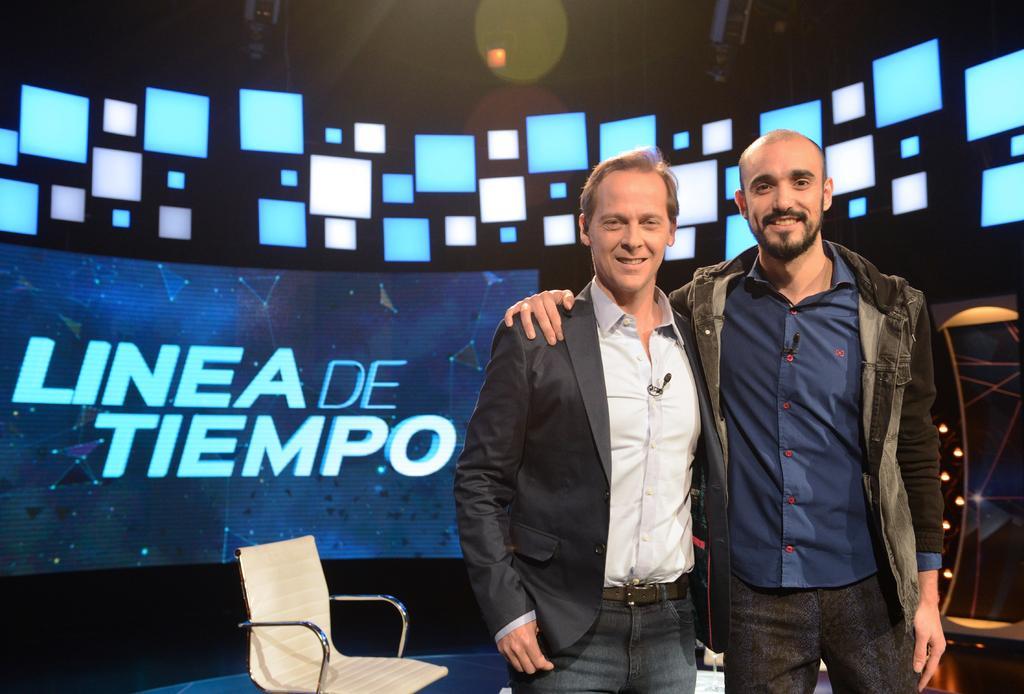Please provide a concise description of this image. In this image i can see 2 persons wearing jackets standing and smiling. In the background i can see a chair,a screen and few lights. 